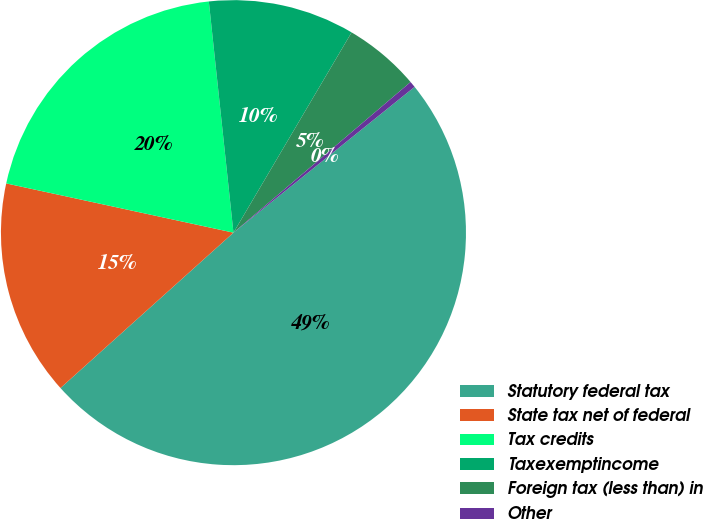<chart> <loc_0><loc_0><loc_500><loc_500><pie_chart><fcel>Statutory federal tax<fcel>State tax net of federal<fcel>Tax credits<fcel>Taxexemptincome<fcel>Foreign tax (less than) in<fcel>Other<nl><fcel>49.13%<fcel>15.04%<fcel>19.91%<fcel>10.17%<fcel>5.3%<fcel>0.43%<nl></chart> 